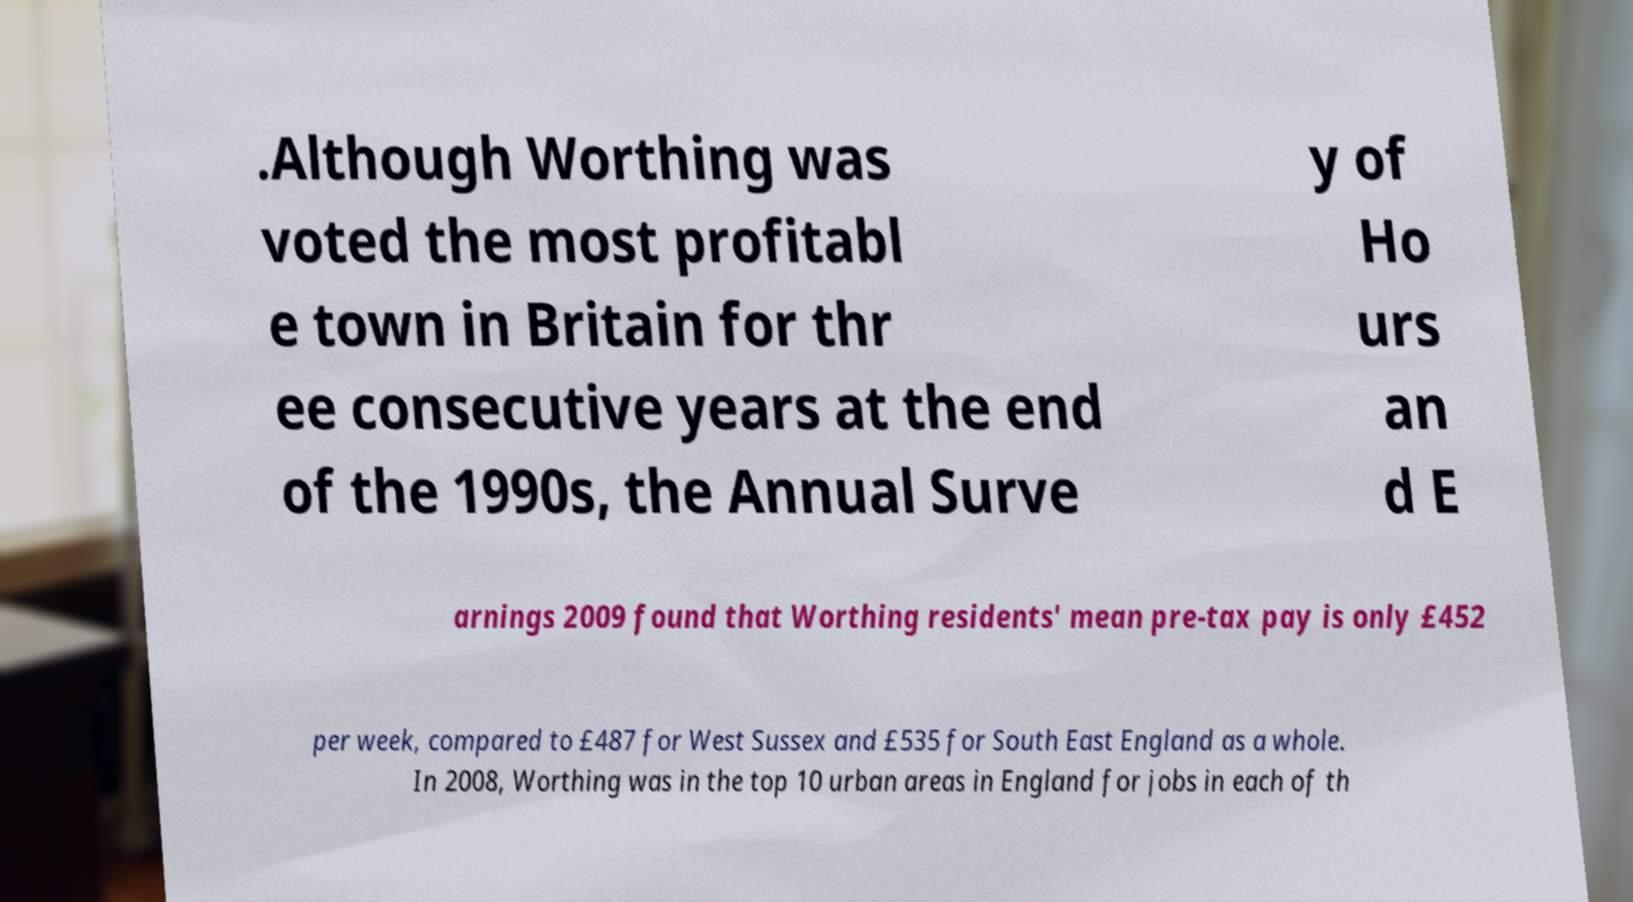There's text embedded in this image that I need extracted. Can you transcribe it verbatim? .Although Worthing was voted the most profitabl e town in Britain for thr ee consecutive years at the end of the 1990s, the Annual Surve y of Ho urs an d E arnings 2009 found that Worthing residents' mean pre-tax pay is only £452 per week, compared to £487 for West Sussex and £535 for South East England as a whole. In 2008, Worthing was in the top 10 urban areas in England for jobs in each of th 